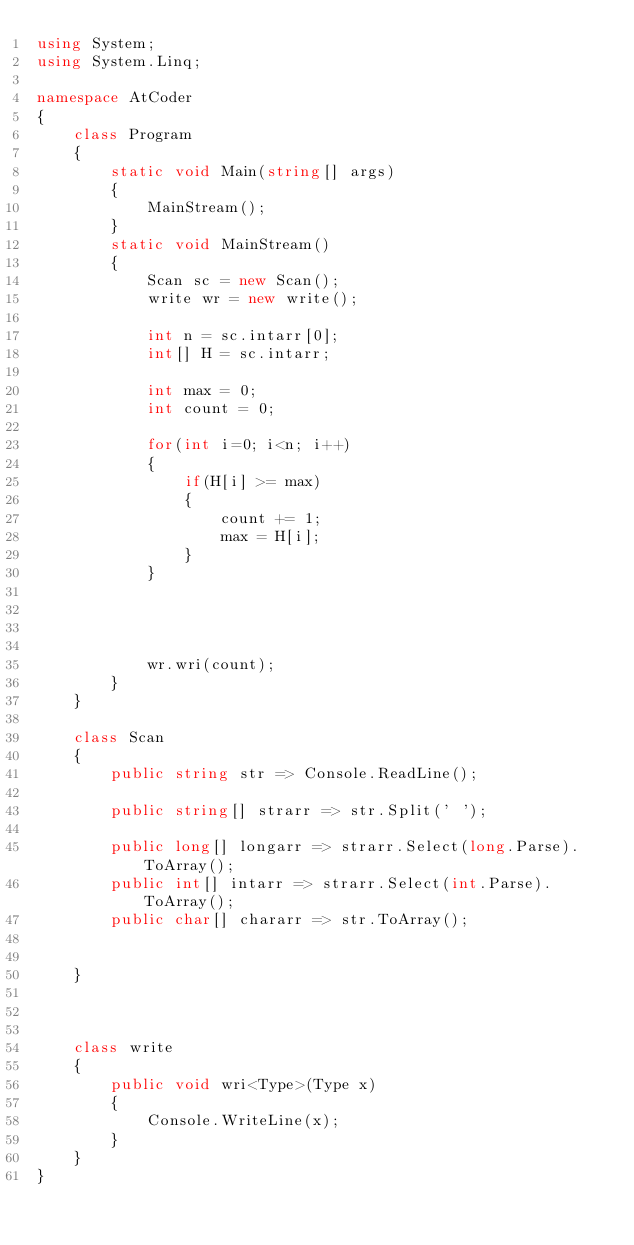<code> <loc_0><loc_0><loc_500><loc_500><_C#_>using System;
using System.Linq;

namespace AtCoder
{
    class Program
    {
        static void Main(string[] args)
        {
            MainStream();
        }
        static void MainStream()
        {
            Scan sc = new Scan();
            write wr = new write();

            int n = sc.intarr[0];
            int[] H = sc.intarr;

            int max = 0;
            int count = 0;

            for(int i=0; i<n; i++)
            {
                if(H[i] >= max)
                {
                    count += 1;
                    max = H[i];
                }
            }




            wr.wri(count);
        }
    }

    class Scan
    {
        public string str => Console.ReadLine();

        public string[] strarr => str.Split(' ');

        public long[] longarr => strarr.Select(long.Parse).ToArray();
        public int[] intarr => strarr.Select(int.Parse).ToArray();
        public char[] chararr => str.ToArray();


    }



    class write
    {
        public void wri<Type>(Type x)
        {
            Console.WriteLine(x);
        }
    }
}
</code> 